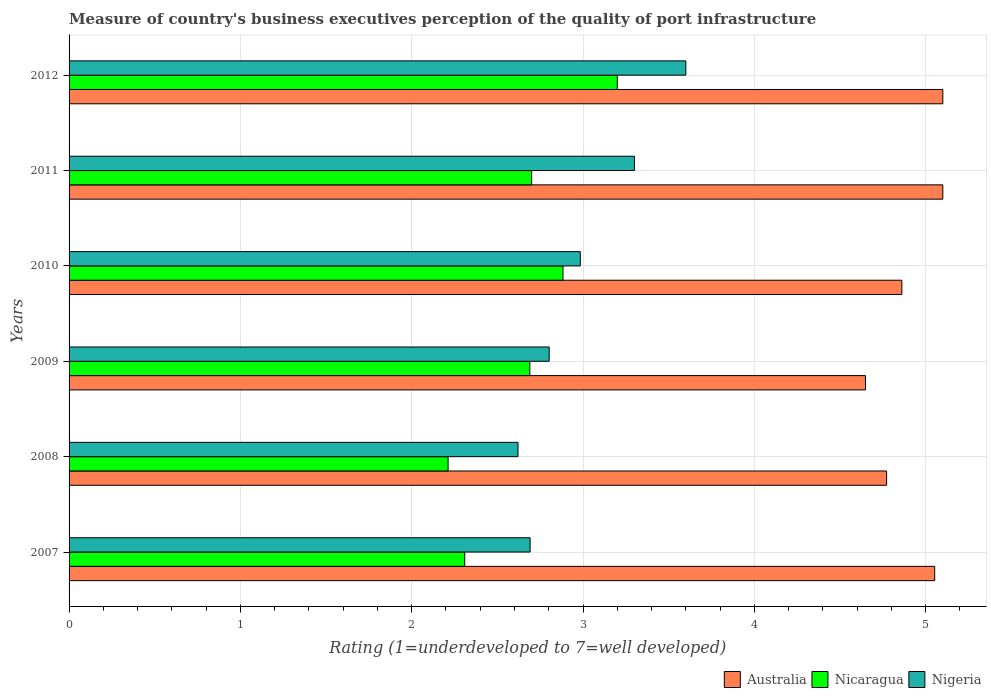Are the number of bars per tick equal to the number of legend labels?
Offer a very short reply. Yes. What is the label of the 4th group of bars from the top?
Ensure brevity in your answer.  2009. What is the ratings of the quality of port infrastructure in Australia in 2010?
Your response must be concise. 4.86. Across all years, what is the minimum ratings of the quality of port infrastructure in Australia?
Keep it short and to the point. 4.65. In which year was the ratings of the quality of port infrastructure in Australia maximum?
Provide a short and direct response. 2011. What is the total ratings of the quality of port infrastructure in Nigeria in the graph?
Offer a terse response. 18. What is the difference between the ratings of the quality of port infrastructure in Nigeria in 2010 and that in 2011?
Your response must be concise. -0.32. What is the difference between the ratings of the quality of port infrastructure in Nigeria in 2009 and the ratings of the quality of port infrastructure in Nicaragua in 2008?
Keep it short and to the point. 0.59. What is the average ratings of the quality of port infrastructure in Nicaragua per year?
Your answer should be compact. 2.67. In the year 2012, what is the difference between the ratings of the quality of port infrastructure in Nicaragua and ratings of the quality of port infrastructure in Nigeria?
Provide a short and direct response. -0.4. What is the ratio of the ratings of the quality of port infrastructure in Nicaragua in 2007 to that in 2012?
Keep it short and to the point. 0.72. Is the ratings of the quality of port infrastructure in Nicaragua in 2008 less than that in 2012?
Keep it short and to the point. Yes. What is the difference between the highest and the second highest ratings of the quality of port infrastructure in Nicaragua?
Your response must be concise. 0.32. What is the difference between the highest and the lowest ratings of the quality of port infrastructure in Australia?
Offer a very short reply. 0.45. In how many years, is the ratings of the quality of port infrastructure in Nicaragua greater than the average ratings of the quality of port infrastructure in Nicaragua taken over all years?
Give a very brief answer. 4. Is the sum of the ratings of the quality of port infrastructure in Nicaragua in 2009 and 2011 greater than the maximum ratings of the quality of port infrastructure in Nigeria across all years?
Give a very brief answer. Yes. What does the 1st bar from the top in 2010 represents?
Keep it short and to the point. Nigeria. What does the 2nd bar from the bottom in 2008 represents?
Provide a succinct answer. Nicaragua. How many bars are there?
Provide a succinct answer. 18. How many years are there in the graph?
Make the answer very short. 6. Does the graph contain any zero values?
Keep it short and to the point. No. Does the graph contain grids?
Your answer should be compact. Yes. How are the legend labels stacked?
Keep it short and to the point. Horizontal. What is the title of the graph?
Your answer should be very brief. Measure of country's business executives perception of the quality of port infrastructure. Does "Mongolia" appear as one of the legend labels in the graph?
Your response must be concise. No. What is the label or title of the X-axis?
Make the answer very short. Rating (1=underdeveloped to 7=well developed). What is the Rating (1=underdeveloped to 7=well developed) in Australia in 2007?
Give a very brief answer. 5.05. What is the Rating (1=underdeveloped to 7=well developed) of Nicaragua in 2007?
Make the answer very short. 2.31. What is the Rating (1=underdeveloped to 7=well developed) of Nigeria in 2007?
Your response must be concise. 2.69. What is the Rating (1=underdeveloped to 7=well developed) of Australia in 2008?
Provide a short and direct response. 4.77. What is the Rating (1=underdeveloped to 7=well developed) in Nicaragua in 2008?
Ensure brevity in your answer.  2.21. What is the Rating (1=underdeveloped to 7=well developed) of Nigeria in 2008?
Offer a very short reply. 2.62. What is the Rating (1=underdeveloped to 7=well developed) in Australia in 2009?
Make the answer very short. 4.65. What is the Rating (1=underdeveloped to 7=well developed) of Nicaragua in 2009?
Provide a succinct answer. 2.69. What is the Rating (1=underdeveloped to 7=well developed) of Nigeria in 2009?
Your answer should be compact. 2.8. What is the Rating (1=underdeveloped to 7=well developed) of Australia in 2010?
Your answer should be compact. 4.86. What is the Rating (1=underdeveloped to 7=well developed) of Nicaragua in 2010?
Provide a succinct answer. 2.88. What is the Rating (1=underdeveloped to 7=well developed) in Nigeria in 2010?
Your answer should be very brief. 2.98. What is the Rating (1=underdeveloped to 7=well developed) of Australia in 2011?
Your answer should be compact. 5.1. What is the Rating (1=underdeveloped to 7=well developed) of Nicaragua in 2011?
Make the answer very short. 2.7. What is the Rating (1=underdeveloped to 7=well developed) of Nigeria in 2011?
Your answer should be very brief. 3.3. Across all years, what is the minimum Rating (1=underdeveloped to 7=well developed) in Australia?
Your answer should be very brief. 4.65. Across all years, what is the minimum Rating (1=underdeveloped to 7=well developed) of Nicaragua?
Ensure brevity in your answer.  2.21. Across all years, what is the minimum Rating (1=underdeveloped to 7=well developed) of Nigeria?
Provide a succinct answer. 2.62. What is the total Rating (1=underdeveloped to 7=well developed) of Australia in the graph?
Ensure brevity in your answer.  29.53. What is the total Rating (1=underdeveloped to 7=well developed) in Nicaragua in the graph?
Provide a succinct answer. 15.99. What is the total Rating (1=underdeveloped to 7=well developed) in Nigeria in the graph?
Offer a very short reply. 18. What is the difference between the Rating (1=underdeveloped to 7=well developed) of Australia in 2007 and that in 2008?
Your answer should be compact. 0.28. What is the difference between the Rating (1=underdeveloped to 7=well developed) in Nicaragua in 2007 and that in 2008?
Provide a succinct answer. 0.1. What is the difference between the Rating (1=underdeveloped to 7=well developed) of Nigeria in 2007 and that in 2008?
Ensure brevity in your answer.  0.07. What is the difference between the Rating (1=underdeveloped to 7=well developed) of Australia in 2007 and that in 2009?
Ensure brevity in your answer.  0.4. What is the difference between the Rating (1=underdeveloped to 7=well developed) of Nicaragua in 2007 and that in 2009?
Offer a terse response. -0.38. What is the difference between the Rating (1=underdeveloped to 7=well developed) in Nigeria in 2007 and that in 2009?
Your answer should be compact. -0.11. What is the difference between the Rating (1=underdeveloped to 7=well developed) in Australia in 2007 and that in 2010?
Your answer should be very brief. 0.19. What is the difference between the Rating (1=underdeveloped to 7=well developed) of Nicaragua in 2007 and that in 2010?
Give a very brief answer. -0.57. What is the difference between the Rating (1=underdeveloped to 7=well developed) of Nigeria in 2007 and that in 2010?
Give a very brief answer. -0.29. What is the difference between the Rating (1=underdeveloped to 7=well developed) in Australia in 2007 and that in 2011?
Keep it short and to the point. -0.05. What is the difference between the Rating (1=underdeveloped to 7=well developed) in Nicaragua in 2007 and that in 2011?
Give a very brief answer. -0.39. What is the difference between the Rating (1=underdeveloped to 7=well developed) in Nigeria in 2007 and that in 2011?
Give a very brief answer. -0.61. What is the difference between the Rating (1=underdeveloped to 7=well developed) in Australia in 2007 and that in 2012?
Make the answer very short. -0.05. What is the difference between the Rating (1=underdeveloped to 7=well developed) of Nicaragua in 2007 and that in 2012?
Your answer should be very brief. -0.89. What is the difference between the Rating (1=underdeveloped to 7=well developed) in Nigeria in 2007 and that in 2012?
Your answer should be very brief. -0.91. What is the difference between the Rating (1=underdeveloped to 7=well developed) in Australia in 2008 and that in 2009?
Make the answer very short. 0.12. What is the difference between the Rating (1=underdeveloped to 7=well developed) in Nicaragua in 2008 and that in 2009?
Make the answer very short. -0.48. What is the difference between the Rating (1=underdeveloped to 7=well developed) of Nigeria in 2008 and that in 2009?
Make the answer very short. -0.18. What is the difference between the Rating (1=underdeveloped to 7=well developed) of Australia in 2008 and that in 2010?
Make the answer very short. -0.09. What is the difference between the Rating (1=underdeveloped to 7=well developed) in Nicaragua in 2008 and that in 2010?
Provide a short and direct response. -0.67. What is the difference between the Rating (1=underdeveloped to 7=well developed) in Nigeria in 2008 and that in 2010?
Give a very brief answer. -0.36. What is the difference between the Rating (1=underdeveloped to 7=well developed) of Australia in 2008 and that in 2011?
Offer a terse response. -0.33. What is the difference between the Rating (1=underdeveloped to 7=well developed) in Nicaragua in 2008 and that in 2011?
Provide a succinct answer. -0.49. What is the difference between the Rating (1=underdeveloped to 7=well developed) of Nigeria in 2008 and that in 2011?
Provide a succinct answer. -0.68. What is the difference between the Rating (1=underdeveloped to 7=well developed) of Australia in 2008 and that in 2012?
Your answer should be compact. -0.33. What is the difference between the Rating (1=underdeveloped to 7=well developed) of Nicaragua in 2008 and that in 2012?
Offer a terse response. -0.99. What is the difference between the Rating (1=underdeveloped to 7=well developed) of Nigeria in 2008 and that in 2012?
Offer a terse response. -0.98. What is the difference between the Rating (1=underdeveloped to 7=well developed) in Australia in 2009 and that in 2010?
Your answer should be very brief. -0.21. What is the difference between the Rating (1=underdeveloped to 7=well developed) in Nicaragua in 2009 and that in 2010?
Provide a succinct answer. -0.19. What is the difference between the Rating (1=underdeveloped to 7=well developed) of Nigeria in 2009 and that in 2010?
Your answer should be compact. -0.18. What is the difference between the Rating (1=underdeveloped to 7=well developed) in Australia in 2009 and that in 2011?
Provide a succinct answer. -0.45. What is the difference between the Rating (1=underdeveloped to 7=well developed) in Nicaragua in 2009 and that in 2011?
Your answer should be compact. -0.01. What is the difference between the Rating (1=underdeveloped to 7=well developed) in Nigeria in 2009 and that in 2011?
Provide a succinct answer. -0.5. What is the difference between the Rating (1=underdeveloped to 7=well developed) of Australia in 2009 and that in 2012?
Provide a short and direct response. -0.45. What is the difference between the Rating (1=underdeveloped to 7=well developed) in Nicaragua in 2009 and that in 2012?
Make the answer very short. -0.51. What is the difference between the Rating (1=underdeveloped to 7=well developed) in Nigeria in 2009 and that in 2012?
Your answer should be very brief. -0.8. What is the difference between the Rating (1=underdeveloped to 7=well developed) in Australia in 2010 and that in 2011?
Your response must be concise. -0.24. What is the difference between the Rating (1=underdeveloped to 7=well developed) in Nicaragua in 2010 and that in 2011?
Provide a short and direct response. 0.18. What is the difference between the Rating (1=underdeveloped to 7=well developed) of Nigeria in 2010 and that in 2011?
Give a very brief answer. -0.32. What is the difference between the Rating (1=underdeveloped to 7=well developed) in Australia in 2010 and that in 2012?
Give a very brief answer. -0.24. What is the difference between the Rating (1=underdeveloped to 7=well developed) of Nicaragua in 2010 and that in 2012?
Offer a very short reply. -0.32. What is the difference between the Rating (1=underdeveloped to 7=well developed) of Nigeria in 2010 and that in 2012?
Ensure brevity in your answer.  -0.62. What is the difference between the Rating (1=underdeveloped to 7=well developed) in Nicaragua in 2011 and that in 2012?
Make the answer very short. -0.5. What is the difference between the Rating (1=underdeveloped to 7=well developed) in Australia in 2007 and the Rating (1=underdeveloped to 7=well developed) in Nicaragua in 2008?
Your response must be concise. 2.84. What is the difference between the Rating (1=underdeveloped to 7=well developed) in Australia in 2007 and the Rating (1=underdeveloped to 7=well developed) in Nigeria in 2008?
Provide a succinct answer. 2.43. What is the difference between the Rating (1=underdeveloped to 7=well developed) in Nicaragua in 2007 and the Rating (1=underdeveloped to 7=well developed) in Nigeria in 2008?
Offer a terse response. -0.31. What is the difference between the Rating (1=underdeveloped to 7=well developed) of Australia in 2007 and the Rating (1=underdeveloped to 7=well developed) of Nicaragua in 2009?
Offer a very short reply. 2.36. What is the difference between the Rating (1=underdeveloped to 7=well developed) in Australia in 2007 and the Rating (1=underdeveloped to 7=well developed) in Nigeria in 2009?
Provide a succinct answer. 2.25. What is the difference between the Rating (1=underdeveloped to 7=well developed) in Nicaragua in 2007 and the Rating (1=underdeveloped to 7=well developed) in Nigeria in 2009?
Offer a very short reply. -0.49. What is the difference between the Rating (1=underdeveloped to 7=well developed) of Australia in 2007 and the Rating (1=underdeveloped to 7=well developed) of Nicaragua in 2010?
Offer a very short reply. 2.17. What is the difference between the Rating (1=underdeveloped to 7=well developed) in Australia in 2007 and the Rating (1=underdeveloped to 7=well developed) in Nigeria in 2010?
Your answer should be very brief. 2.07. What is the difference between the Rating (1=underdeveloped to 7=well developed) in Nicaragua in 2007 and the Rating (1=underdeveloped to 7=well developed) in Nigeria in 2010?
Your answer should be very brief. -0.67. What is the difference between the Rating (1=underdeveloped to 7=well developed) of Australia in 2007 and the Rating (1=underdeveloped to 7=well developed) of Nicaragua in 2011?
Your answer should be very brief. 2.35. What is the difference between the Rating (1=underdeveloped to 7=well developed) in Australia in 2007 and the Rating (1=underdeveloped to 7=well developed) in Nigeria in 2011?
Your answer should be very brief. 1.75. What is the difference between the Rating (1=underdeveloped to 7=well developed) in Nicaragua in 2007 and the Rating (1=underdeveloped to 7=well developed) in Nigeria in 2011?
Provide a succinct answer. -0.99. What is the difference between the Rating (1=underdeveloped to 7=well developed) in Australia in 2007 and the Rating (1=underdeveloped to 7=well developed) in Nicaragua in 2012?
Offer a very short reply. 1.85. What is the difference between the Rating (1=underdeveloped to 7=well developed) in Australia in 2007 and the Rating (1=underdeveloped to 7=well developed) in Nigeria in 2012?
Offer a terse response. 1.45. What is the difference between the Rating (1=underdeveloped to 7=well developed) in Nicaragua in 2007 and the Rating (1=underdeveloped to 7=well developed) in Nigeria in 2012?
Provide a succinct answer. -1.29. What is the difference between the Rating (1=underdeveloped to 7=well developed) of Australia in 2008 and the Rating (1=underdeveloped to 7=well developed) of Nicaragua in 2009?
Offer a very short reply. 2.08. What is the difference between the Rating (1=underdeveloped to 7=well developed) in Australia in 2008 and the Rating (1=underdeveloped to 7=well developed) in Nigeria in 2009?
Your answer should be compact. 1.97. What is the difference between the Rating (1=underdeveloped to 7=well developed) in Nicaragua in 2008 and the Rating (1=underdeveloped to 7=well developed) in Nigeria in 2009?
Offer a terse response. -0.59. What is the difference between the Rating (1=underdeveloped to 7=well developed) of Australia in 2008 and the Rating (1=underdeveloped to 7=well developed) of Nicaragua in 2010?
Keep it short and to the point. 1.89. What is the difference between the Rating (1=underdeveloped to 7=well developed) of Australia in 2008 and the Rating (1=underdeveloped to 7=well developed) of Nigeria in 2010?
Ensure brevity in your answer.  1.79. What is the difference between the Rating (1=underdeveloped to 7=well developed) in Nicaragua in 2008 and the Rating (1=underdeveloped to 7=well developed) in Nigeria in 2010?
Your answer should be compact. -0.77. What is the difference between the Rating (1=underdeveloped to 7=well developed) of Australia in 2008 and the Rating (1=underdeveloped to 7=well developed) of Nicaragua in 2011?
Offer a terse response. 2.07. What is the difference between the Rating (1=underdeveloped to 7=well developed) in Australia in 2008 and the Rating (1=underdeveloped to 7=well developed) in Nigeria in 2011?
Make the answer very short. 1.47. What is the difference between the Rating (1=underdeveloped to 7=well developed) of Nicaragua in 2008 and the Rating (1=underdeveloped to 7=well developed) of Nigeria in 2011?
Your answer should be very brief. -1.09. What is the difference between the Rating (1=underdeveloped to 7=well developed) of Australia in 2008 and the Rating (1=underdeveloped to 7=well developed) of Nicaragua in 2012?
Your response must be concise. 1.57. What is the difference between the Rating (1=underdeveloped to 7=well developed) of Australia in 2008 and the Rating (1=underdeveloped to 7=well developed) of Nigeria in 2012?
Your response must be concise. 1.17. What is the difference between the Rating (1=underdeveloped to 7=well developed) of Nicaragua in 2008 and the Rating (1=underdeveloped to 7=well developed) of Nigeria in 2012?
Offer a very short reply. -1.39. What is the difference between the Rating (1=underdeveloped to 7=well developed) of Australia in 2009 and the Rating (1=underdeveloped to 7=well developed) of Nicaragua in 2010?
Ensure brevity in your answer.  1.77. What is the difference between the Rating (1=underdeveloped to 7=well developed) of Australia in 2009 and the Rating (1=underdeveloped to 7=well developed) of Nigeria in 2010?
Keep it short and to the point. 1.66. What is the difference between the Rating (1=underdeveloped to 7=well developed) in Nicaragua in 2009 and the Rating (1=underdeveloped to 7=well developed) in Nigeria in 2010?
Ensure brevity in your answer.  -0.29. What is the difference between the Rating (1=underdeveloped to 7=well developed) of Australia in 2009 and the Rating (1=underdeveloped to 7=well developed) of Nicaragua in 2011?
Keep it short and to the point. 1.95. What is the difference between the Rating (1=underdeveloped to 7=well developed) of Australia in 2009 and the Rating (1=underdeveloped to 7=well developed) of Nigeria in 2011?
Provide a short and direct response. 1.35. What is the difference between the Rating (1=underdeveloped to 7=well developed) in Nicaragua in 2009 and the Rating (1=underdeveloped to 7=well developed) in Nigeria in 2011?
Ensure brevity in your answer.  -0.61. What is the difference between the Rating (1=underdeveloped to 7=well developed) in Australia in 2009 and the Rating (1=underdeveloped to 7=well developed) in Nicaragua in 2012?
Your response must be concise. 1.45. What is the difference between the Rating (1=underdeveloped to 7=well developed) in Australia in 2009 and the Rating (1=underdeveloped to 7=well developed) in Nigeria in 2012?
Provide a short and direct response. 1.05. What is the difference between the Rating (1=underdeveloped to 7=well developed) of Nicaragua in 2009 and the Rating (1=underdeveloped to 7=well developed) of Nigeria in 2012?
Keep it short and to the point. -0.91. What is the difference between the Rating (1=underdeveloped to 7=well developed) of Australia in 2010 and the Rating (1=underdeveloped to 7=well developed) of Nicaragua in 2011?
Offer a terse response. 2.16. What is the difference between the Rating (1=underdeveloped to 7=well developed) of Australia in 2010 and the Rating (1=underdeveloped to 7=well developed) of Nigeria in 2011?
Your response must be concise. 1.56. What is the difference between the Rating (1=underdeveloped to 7=well developed) in Nicaragua in 2010 and the Rating (1=underdeveloped to 7=well developed) in Nigeria in 2011?
Your answer should be compact. -0.42. What is the difference between the Rating (1=underdeveloped to 7=well developed) of Australia in 2010 and the Rating (1=underdeveloped to 7=well developed) of Nicaragua in 2012?
Provide a succinct answer. 1.66. What is the difference between the Rating (1=underdeveloped to 7=well developed) of Australia in 2010 and the Rating (1=underdeveloped to 7=well developed) of Nigeria in 2012?
Ensure brevity in your answer.  1.26. What is the difference between the Rating (1=underdeveloped to 7=well developed) of Nicaragua in 2010 and the Rating (1=underdeveloped to 7=well developed) of Nigeria in 2012?
Your answer should be compact. -0.72. What is the difference between the Rating (1=underdeveloped to 7=well developed) of Australia in 2011 and the Rating (1=underdeveloped to 7=well developed) of Nicaragua in 2012?
Make the answer very short. 1.9. What is the difference between the Rating (1=underdeveloped to 7=well developed) in Australia in 2011 and the Rating (1=underdeveloped to 7=well developed) in Nigeria in 2012?
Your response must be concise. 1.5. What is the average Rating (1=underdeveloped to 7=well developed) of Australia per year?
Offer a very short reply. 4.92. What is the average Rating (1=underdeveloped to 7=well developed) of Nicaragua per year?
Offer a very short reply. 2.67. What is the average Rating (1=underdeveloped to 7=well developed) in Nigeria per year?
Your answer should be very brief. 3. In the year 2007, what is the difference between the Rating (1=underdeveloped to 7=well developed) in Australia and Rating (1=underdeveloped to 7=well developed) in Nicaragua?
Keep it short and to the point. 2.74. In the year 2007, what is the difference between the Rating (1=underdeveloped to 7=well developed) of Australia and Rating (1=underdeveloped to 7=well developed) of Nigeria?
Ensure brevity in your answer.  2.36. In the year 2007, what is the difference between the Rating (1=underdeveloped to 7=well developed) of Nicaragua and Rating (1=underdeveloped to 7=well developed) of Nigeria?
Your answer should be compact. -0.38. In the year 2008, what is the difference between the Rating (1=underdeveloped to 7=well developed) of Australia and Rating (1=underdeveloped to 7=well developed) of Nicaragua?
Ensure brevity in your answer.  2.56. In the year 2008, what is the difference between the Rating (1=underdeveloped to 7=well developed) in Australia and Rating (1=underdeveloped to 7=well developed) in Nigeria?
Offer a very short reply. 2.15. In the year 2008, what is the difference between the Rating (1=underdeveloped to 7=well developed) in Nicaragua and Rating (1=underdeveloped to 7=well developed) in Nigeria?
Your answer should be very brief. -0.41. In the year 2009, what is the difference between the Rating (1=underdeveloped to 7=well developed) in Australia and Rating (1=underdeveloped to 7=well developed) in Nicaragua?
Make the answer very short. 1.96. In the year 2009, what is the difference between the Rating (1=underdeveloped to 7=well developed) of Australia and Rating (1=underdeveloped to 7=well developed) of Nigeria?
Your answer should be very brief. 1.85. In the year 2009, what is the difference between the Rating (1=underdeveloped to 7=well developed) of Nicaragua and Rating (1=underdeveloped to 7=well developed) of Nigeria?
Your answer should be very brief. -0.11. In the year 2010, what is the difference between the Rating (1=underdeveloped to 7=well developed) in Australia and Rating (1=underdeveloped to 7=well developed) in Nicaragua?
Give a very brief answer. 1.98. In the year 2010, what is the difference between the Rating (1=underdeveloped to 7=well developed) of Australia and Rating (1=underdeveloped to 7=well developed) of Nigeria?
Your answer should be compact. 1.88. In the year 2010, what is the difference between the Rating (1=underdeveloped to 7=well developed) of Nicaragua and Rating (1=underdeveloped to 7=well developed) of Nigeria?
Ensure brevity in your answer.  -0.1. In the year 2011, what is the difference between the Rating (1=underdeveloped to 7=well developed) in Australia and Rating (1=underdeveloped to 7=well developed) in Nicaragua?
Provide a succinct answer. 2.4. In the year 2011, what is the difference between the Rating (1=underdeveloped to 7=well developed) of Nicaragua and Rating (1=underdeveloped to 7=well developed) of Nigeria?
Offer a very short reply. -0.6. In the year 2012, what is the difference between the Rating (1=underdeveloped to 7=well developed) of Australia and Rating (1=underdeveloped to 7=well developed) of Nicaragua?
Provide a succinct answer. 1.9. What is the ratio of the Rating (1=underdeveloped to 7=well developed) of Australia in 2007 to that in 2008?
Make the answer very short. 1.06. What is the ratio of the Rating (1=underdeveloped to 7=well developed) of Nicaragua in 2007 to that in 2008?
Offer a terse response. 1.04. What is the ratio of the Rating (1=underdeveloped to 7=well developed) of Nigeria in 2007 to that in 2008?
Offer a very short reply. 1.03. What is the ratio of the Rating (1=underdeveloped to 7=well developed) of Australia in 2007 to that in 2009?
Ensure brevity in your answer.  1.09. What is the ratio of the Rating (1=underdeveloped to 7=well developed) in Nicaragua in 2007 to that in 2009?
Give a very brief answer. 0.86. What is the ratio of the Rating (1=underdeveloped to 7=well developed) in Nigeria in 2007 to that in 2009?
Offer a very short reply. 0.96. What is the ratio of the Rating (1=underdeveloped to 7=well developed) in Australia in 2007 to that in 2010?
Ensure brevity in your answer.  1.04. What is the ratio of the Rating (1=underdeveloped to 7=well developed) of Nicaragua in 2007 to that in 2010?
Provide a succinct answer. 0.8. What is the ratio of the Rating (1=underdeveloped to 7=well developed) in Nigeria in 2007 to that in 2010?
Provide a short and direct response. 0.9. What is the ratio of the Rating (1=underdeveloped to 7=well developed) of Australia in 2007 to that in 2011?
Provide a short and direct response. 0.99. What is the ratio of the Rating (1=underdeveloped to 7=well developed) of Nicaragua in 2007 to that in 2011?
Your response must be concise. 0.86. What is the ratio of the Rating (1=underdeveloped to 7=well developed) of Nigeria in 2007 to that in 2011?
Keep it short and to the point. 0.82. What is the ratio of the Rating (1=underdeveloped to 7=well developed) of Nicaragua in 2007 to that in 2012?
Offer a very short reply. 0.72. What is the ratio of the Rating (1=underdeveloped to 7=well developed) of Nigeria in 2007 to that in 2012?
Your response must be concise. 0.75. What is the ratio of the Rating (1=underdeveloped to 7=well developed) in Australia in 2008 to that in 2009?
Your response must be concise. 1.03. What is the ratio of the Rating (1=underdeveloped to 7=well developed) in Nicaragua in 2008 to that in 2009?
Provide a short and direct response. 0.82. What is the ratio of the Rating (1=underdeveloped to 7=well developed) in Nigeria in 2008 to that in 2009?
Ensure brevity in your answer.  0.94. What is the ratio of the Rating (1=underdeveloped to 7=well developed) in Australia in 2008 to that in 2010?
Keep it short and to the point. 0.98. What is the ratio of the Rating (1=underdeveloped to 7=well developed) of Nicaragua in 2008 to that in 2010?
Your answer should be very brief. 0.77. What is the ratio of the Rating (1=underdeveloped to 7=well developed) of Nigeria in 2008 to that in 2010?
Offer a terse response. 0.88. What is the ratio of the Rating (1=underdeveloped to 7=well developed) in Australia in 2008 to that in 2011?
Offer a very short reply. 0.94. What is the ratio of the Rating (1=underdeveloped to 7=well developed) in Nicaragua in 2008 to that in 2011?
Make the answer very short. 0.82. What is the ratio of the Rating (1=underdeveloped to 7=well developed) in Nigeria in 2008 to that in 2011?
Offer a terse response. 0.79. What is the ratio of the Rating (1=underdeveloped to 7=well developed) of Australia in 2008 to that in 2012?
Ensure brevity in your answer.  0.94. What is the ratio of the Rating (1=underdeveloped to 7=well developed) in Nicaragua in 2008 to that in 2012?
Your answer should be very brief. 0.69. What is the ratio of the Rating (1=underdeveloped to 7=well developed) in Nigeria in 2008 to that in 2012?
Your answer should be compact. 0.73. What is the ratio of the Rating (1=underdeveloped to 7=well developed) of Australia in 2009 to that in 2010?
Keep it short and to the point. 0.96. What is the ratio of the Rating (1=underdeveloped to 7=well developed) of Nicaragua in 2009 to that in 2010?
Provide a short and direct response. 0.93. What is the ratio of the Rating (1=underdeveloped to 7=well developed) of Nigeria in 2009 to that in 2010?
Provide a succinct answer. 0.94. What is the ratio of the Rating (1=underdeveloped to 7=well developed) in Australia in 2009 to that in 2011?
Keep it short and to the point. 0.91. What is the ratio of the Rating (1=underdeveloped to 7=well developed) of Nigeria in 2009 to that in 2011?
Give a very brief answer. 0.85. What is the ratio of the Rating (1=underdeveloped to 7=well developed) in Australia in 2009 to that in 2012?
Provide a succinct answer. 0.91. What is the ratio of the Rating (1=underdeveloped to 7=well developed) in Nicaragua in 2009 to that in 2012?
Offer a very short reply. 0.84. What is the ratio of the Rating (1=underdeveloped to 7=well developed) of Nigeria in 2009 to that in 2012?
Offer a terse response. 0.78. What is the ratio of the Rating (1=underdeveloped to 7=well developed) of Australia in 2010 to that in 2011?
Give a very brief answer. 0.95. What is the ratio of the Rating (1=underdeveloped to 7=well developed) in Nicaragua in 2010 to that in 2011?
Your answer should be compact. 1.07. What is the ratio of the Rating (1=underdeveloped to 7=well developed) in Nigeria in 2010 to that in 2011?
Make the answer very short. 0.9. What is the ratio of the Rating (1=underdeveloped to 7=well developed) of Australia in 2010 to that in 2012?
Provide a succinct answer. 0.95. What is the ratio of the Rating (1=underdeveloped to 7=well developed) of Nicaragua in 2010 to that in 2012?
Provide a succinct answer. 0.9. What is the ratio of the Rating (1=underdeveloped to 7=well developed) of Nigeria in 2010 to that in 2012?
Ensure brevity in your answer.  0.83. What is the ratio of the Rating (1=underdeveloped to 7=well developed) in Australia in 2011 to that in 2012?
Offer a terse response. 1. What is the ratio of the Rating (1=underdeveloped to 7=well developed) in Nicaragua in 2011 to that in 2012?
Your response must be concise. 0.84. What is the difference between the highest and the second highest Rating (1=underdeveloped to 7=well developed) in Nicaragua?
Provide a short and direct response. 0.32. What is the difference between the highest and the lowest Rating (1=underdeveloped to 7=well developed) in Australia?
Keep it short and to the point. 0.45. What is the difference between the highest and the lowest Rating (1=underdeveloped to 7=well developed) of Nigeria?
Offer a terse response. 0.98. 